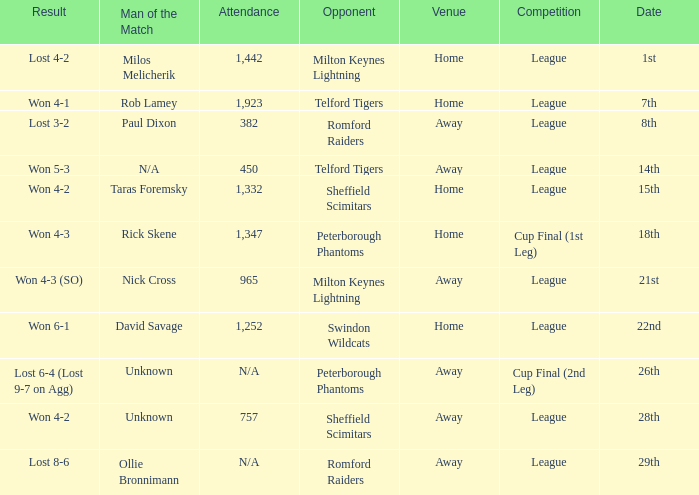Who was the Man of the Match when the opponent was Milton Keynes Lightning and the venue was Away? Nick Cross. 